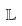Convert formula to latex. <formula><loc_0><loc_0><loc_500><loc_500>\mathbb { L }</formula> 